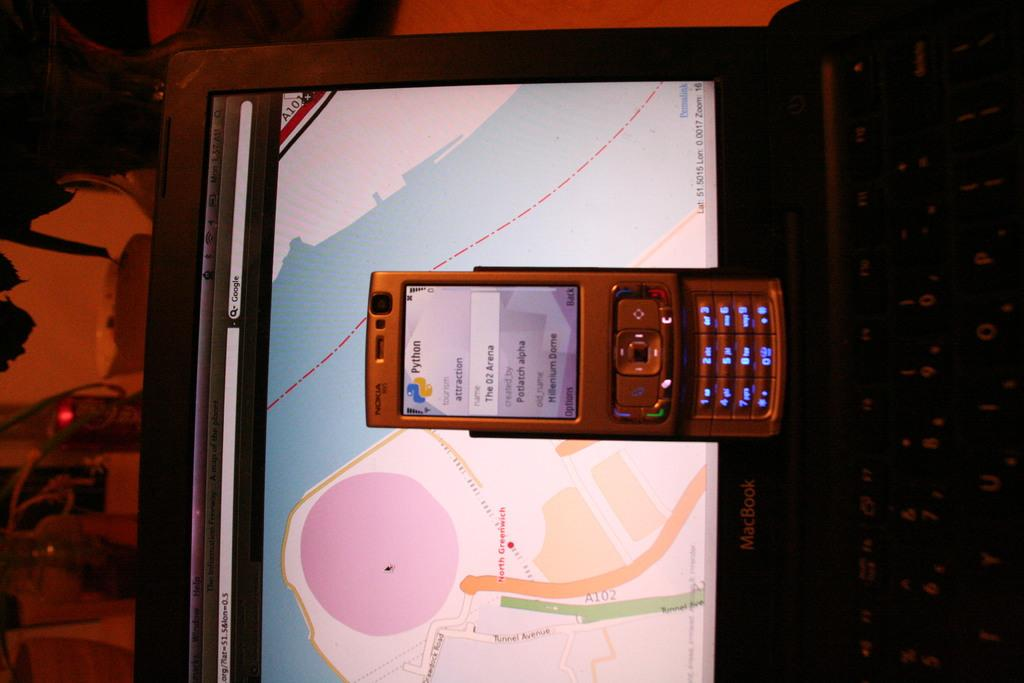<image>
Describe the image concisely. the number 2 is on the front of a phone 